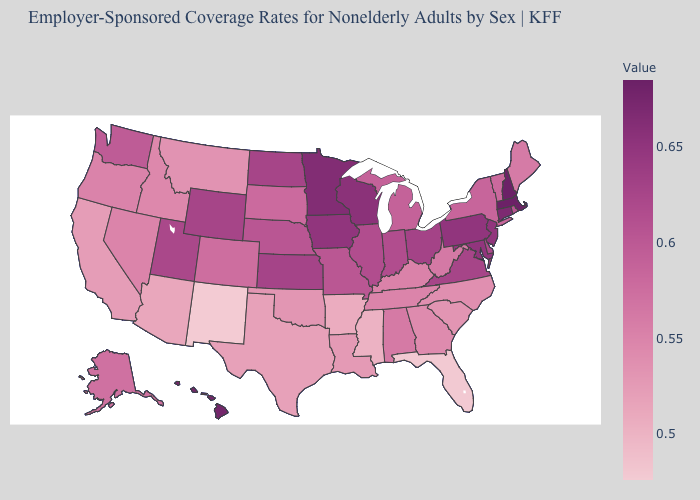Which states have the lowest value in the USA?
Write a very short answer. New Mexico. Does Virginia have a lower value than South Carolina?
Write a very short answer. No. Does Maine have the lowest value in the USA?
Give a very brief answer. No. 